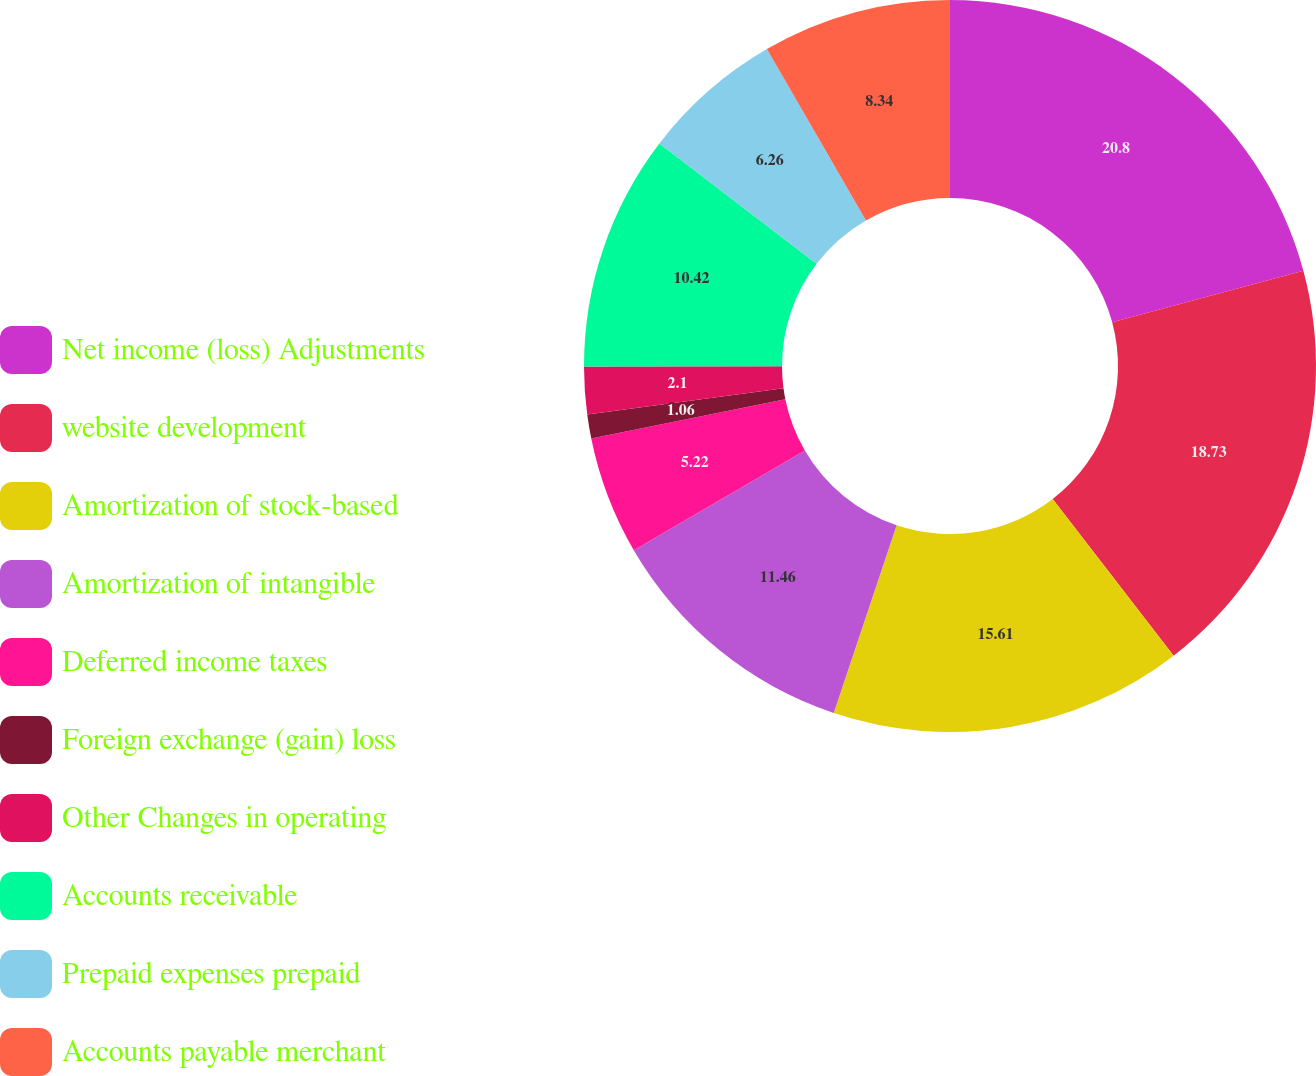Convert chart to OTSL. <chart><loc_0><loc_0><loc_500><loc_500><pie_chart><fcel>Net income (loss) Adjustments<fcel>website development<fcel>Amortization of stock-based<fcel>Amortization of intangible<fcel>Deferred income taxes<fcel>Foreign exchange (gain) loss<fcel>Other Changes in operating<fcel>Accounts receivable<fcel>Prepaid expenses prepaid<fcel>Accounts payable merchant<nl><fcel>20.81%<fcel>18.73%<fcel>15.61%<fcel>11.46%<fcel>5.22%<fcel>1.06%<fcel>2.1%<fcel>10.42%<fcel>6.26%<fcel>8.34%<nl></chart> 